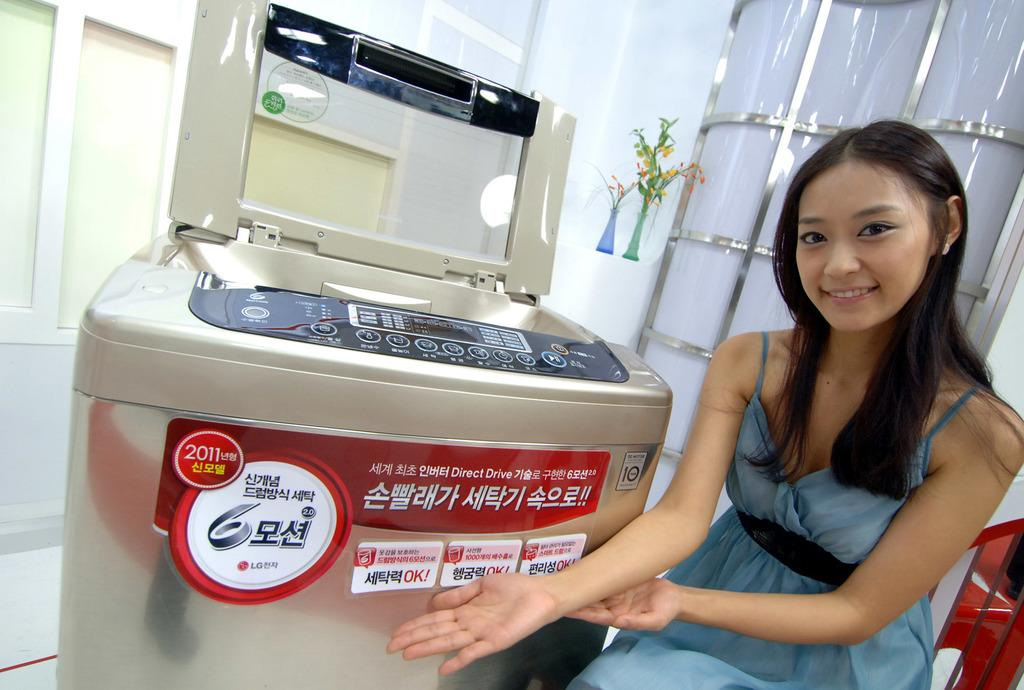Provide a one-sentence caption for the provided image. A young woman sits next to a 2011 LG printing machine. 